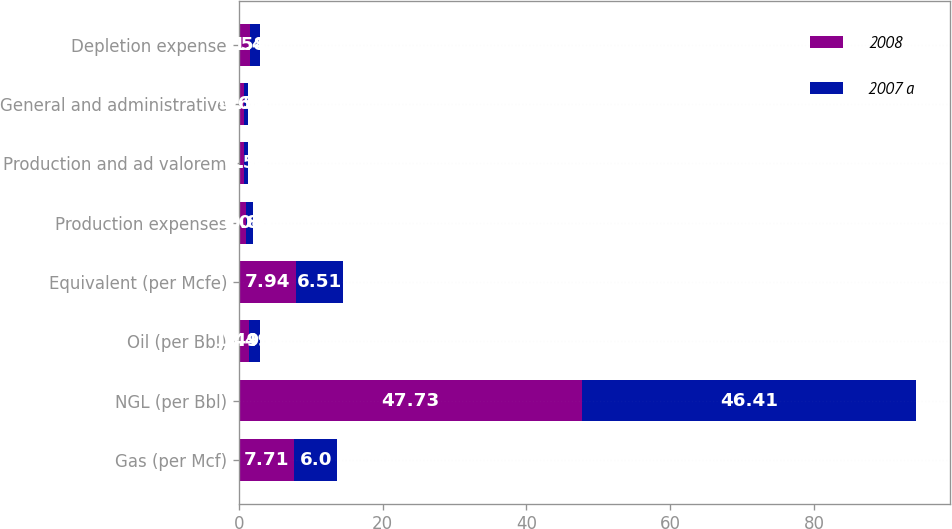Convert chart to OTSL. <chart><loc_0><loc_0><loc_500><loc_500><stacked_bar_chart><ecel><fcel>Gas (per Mcf)<fcel>NGL (per Bbl)<fcel>Oil (per Bbl)<fcel>Equivalent (per Mcfe)<fcel>Production expenses<fcel>Production and ad valorem<fcel>General and administrative<fcel>Depletion expense<nl><fcel>2008<fcel>7.71<fcel>47.73<fcel>1.495<fcel>7.94<fcel>1.04<fcel>0.7<fcel>0.69<fcel>1.58<nl><fcel>2007 a<fcel>6<fcel>46.41<fcel>1.495<fcel>6.51<fcel>0.89<fcel>0.54<fcel>0.58<fcel>1.41<nl></chart> 